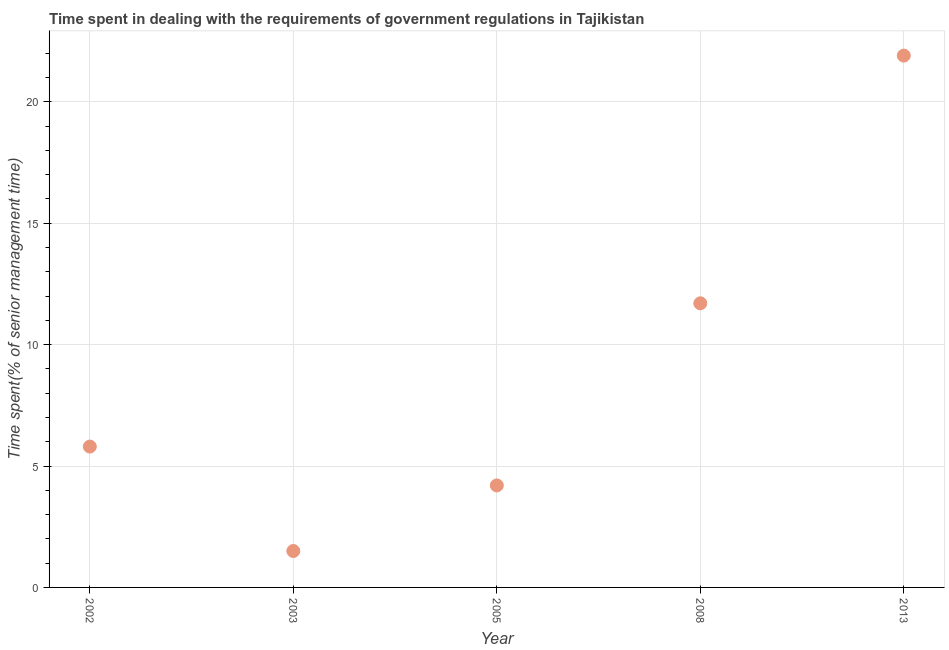What is the time spent in dealing with government regulations in 2013?
Offer a terse response. 21.9. Across all years, what is the maximum time spent in dealing with government regulations?
Provide a short and direct response. 21.9. Across all years, what is the minimum time spent in dealing with government regulations?
Your response must be concise. 1.5. In which year was the time spent in dealing with government regulations maximum?
Provide a succinct answer. 2013. What is the sum of the time spent in dealing with government regulations?
Offer a terse response. 45.1. What is the difference between the time spent in dealing with government regulations in 2005 and 2008?
Offer a very short reply. -7.5. What is the average time spent in dealing with government regulations per year?
Provide a succinct answer. 9.02. In how many years, is the time spent in dealing with government regulations greater than 12 %?
Make the answer very short. 1. What is the ratio of the time spent in dealing with government regulations in 2003 to that in 2008?
Ensure brevity in your answer.  0.13. What is the difference between the highest and the lowest time spent in dealing with government regulations?
Your answer should be very brief. 20.4. In how many years, is the time spent in dealing with government regulations greater than the average time spent in dealing with government regulations taken over all years?
Give a very brief answer. 2. Does the time spent in dealing with government regulations monotonically increase over the years?
Provide a succinct answer. No. Does the graph contain grids?
Your answer should be compact. Yes. What is the title of the graph?
Provide a succinct answer. Time spent in dealing with the requirements of government regulations in Tajikistan. What is the label or title of the Y-axis?
Offer a very short reply. Time spent(% of senior management time). What is the Time spent(% of senior management time) in 2002?
Offer a terse response. 5.8. What is the Time spent(% of senior management time) in 2005?
Provide a short and direct response. 4.2. What is the Time spent(% of senior management time) in 2008?
Provide a succinct answer. 11.7. What is the Time spent(% of senior management time) in 2013?
Keep it short and to the point. 21.9. What is the difference between the Time spent(% of senior management time) in 2002 and 2005?
Your response must be concise. 1.6. What is the difference between the Time spent(% of senior management time) in 2002 and 2008?
Offer a very short reply. -5.9. What is the difference between the Time spent(% of senior management time) in 2002 and 2013?
Give a very brief answer. -16.1. What is the difference between the Time spent(% of senior management time) in 2003 and 2005?
Offer a very short reply. -2.7. What is the difference between the Time spent(% of senior management time) in 2003 and 2008?
Provide a short and direct response. -10.2. What is the difference between the Time spent(% of senior management time) in 2003 and 2013?
Offer a terse response. -20.4. What is the difference between the Time spent(% of senior management time) in 2005 and 2008?
Offer a very short reply. -7.5. What is the difference between the Time spent(% of senior management time) in 2005 and 2013?
Your answer should be very brief. -17.7. What is the ratio of the Time spent(% of senior management time) in 2002 to that in 2003?
Your response must be concise. 3.87. What is the ratio of the Time spent(% of senior management time) in 2002 to that in 2005?
Your answer should be compact. 1.38. What is the ratio of the Time spent(% of senior management time) in 2002 to that in 2008?
Offer a terse response. 0.5. What is the ratio of the Time spent(% of senior management time) in 2002 to that in 2013?
Give a very brief answer. 0.27. What is the ratio of the Time spent(% of senior management time) in 2003 to that in 2005?
Give a very brief answer. 0.36. What is the ratio of the Time spent(% of senior management time) in 2003 to that in 2008?
Give a very brief answer. 0.13. What is the ratio of the Time spent(% of senior management time) in 2003 to that in 2013?
Your response must be concise. 0.07. What is the ratio of the Time spent(% of senior management time) in 2005 to that in 2008?
Provide a succinct answer. 0.36. What is the ratio of the Time spent(% of senior management time) in 2005 to that in 2013?
Offer a very short reply. 0.19. What is the ratio of the Time spent(% of senior management time) in 2008 to that in 2013?
Give a very brief answer. 0.53. 